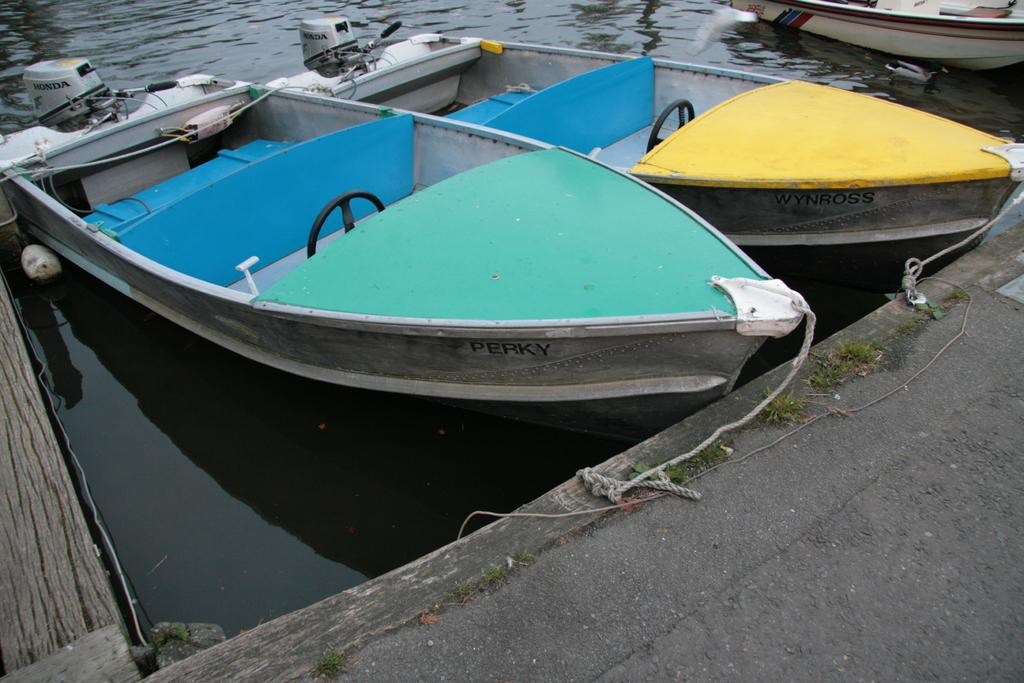What is on the water in the image? There are boats on the water in the image. What can be seen connecting the boats or other objects in the image? Ropes are visible in the image. What type of vegetation is present in the image? There is grass present in the image. What material is used for some objects in the image? There are wooden objects in the image. What type of grain is being harvested in the image? There is no grain present in the image; it features boats on the water, ropes, grass, and wooden objects. 